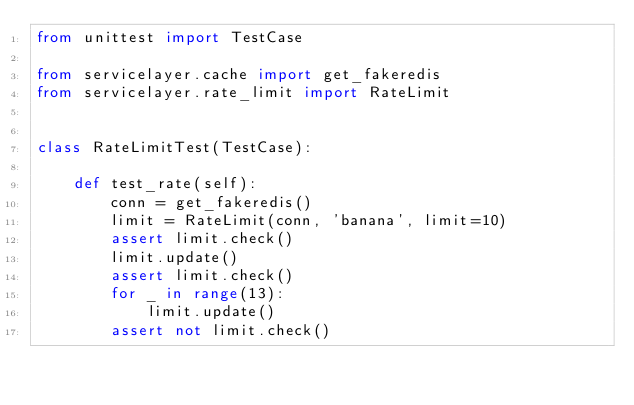<code> <loc_0><loc_0><loc_500><loc_500><_Python_>from unittest import TestCase

from servicelayer.cache import get_fakeredis
from servicelayer.rate_limit import RateLimit


class RateLimitTest(TestCase):

    def test_rate(self):
        conn = get_fakeredis()
        limit = RateLimit(conn, 'banana', limit=10)
        assert limit.check()
        limit.update()
        assert limit.check()
        for _ in range(13):
            limit.update()
        assert not limit.check()
</code> 